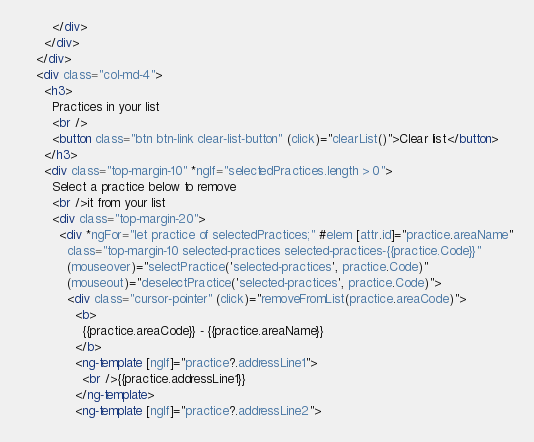<code> <loc_0><loc_0><loc_500><loc_500><_HTML_>        </div>
      </div>
    </div>
    <div class="col-md-4">
      <h3>
        Practices in your list
        <br />
        <button class="btn btn-link clear-list-button" (click)="clearList()">Clear list</button>
      </h3>
      <div class="top-margin-10" *ngIf="selectedPractices.length > 0">
        Select a practice below to remove
        <br />it from your list
        <div class="top-margin-20">
          <div *ngFor="let practice of selectedPractices;" #elem [attr.id]="practice.areaName"
            class="top-margin-10 selected-practices selected-practices-{{practice.Code}}"
            (mouseover)="selectPractice('selected-practices', practice.Code)"
            (mouseout)="deselectPractice('selected-practices', practice.Code)">
            <div class="cursor-pointer" (click)="removeFromList(practice.areaCode)">
              <b>
                {{practice.areaCode}} - {{practice.areaName}}
              </b>
              <ng-template [ngIf]="practice?.addressLine1">
                <br />{{practice.addressLine1}}
              </ng-template>
              <ng-template [ngIf]="practice?.addressLine2"></code> 